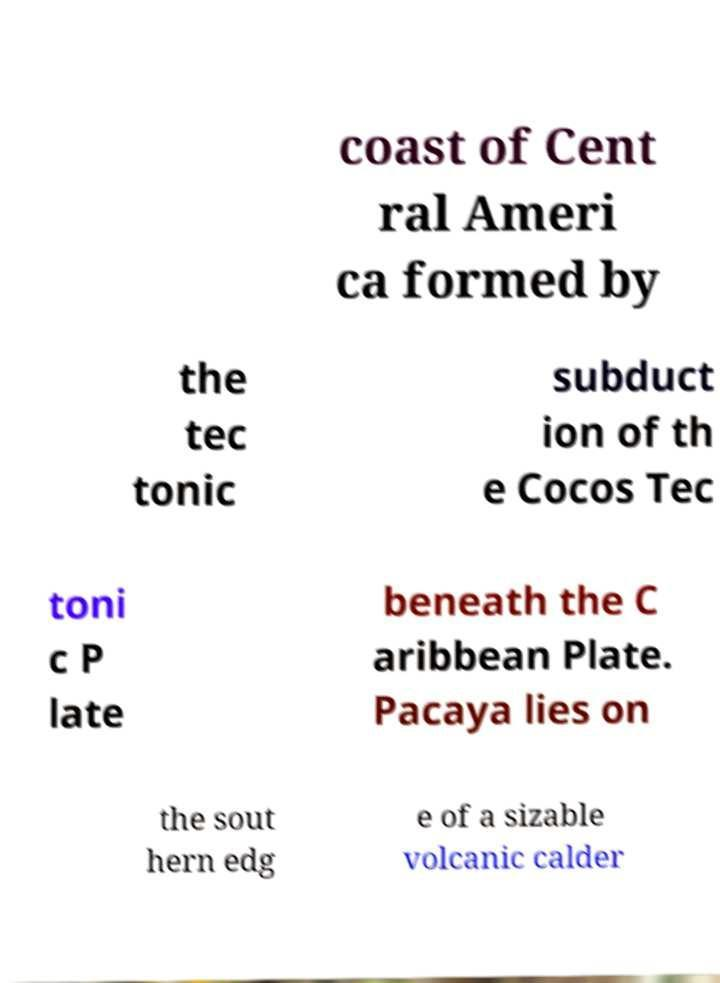What messages or text are displayed in this image? I need them in a readable, typed format. coast of Cent ral Ameri ca formed by the tec tonic subduct ion of th e Cocos Tec toni c P late beneath the C aribbean Plate. Pacaya lies on the sout hern edg e of a sizable volcanic calder 